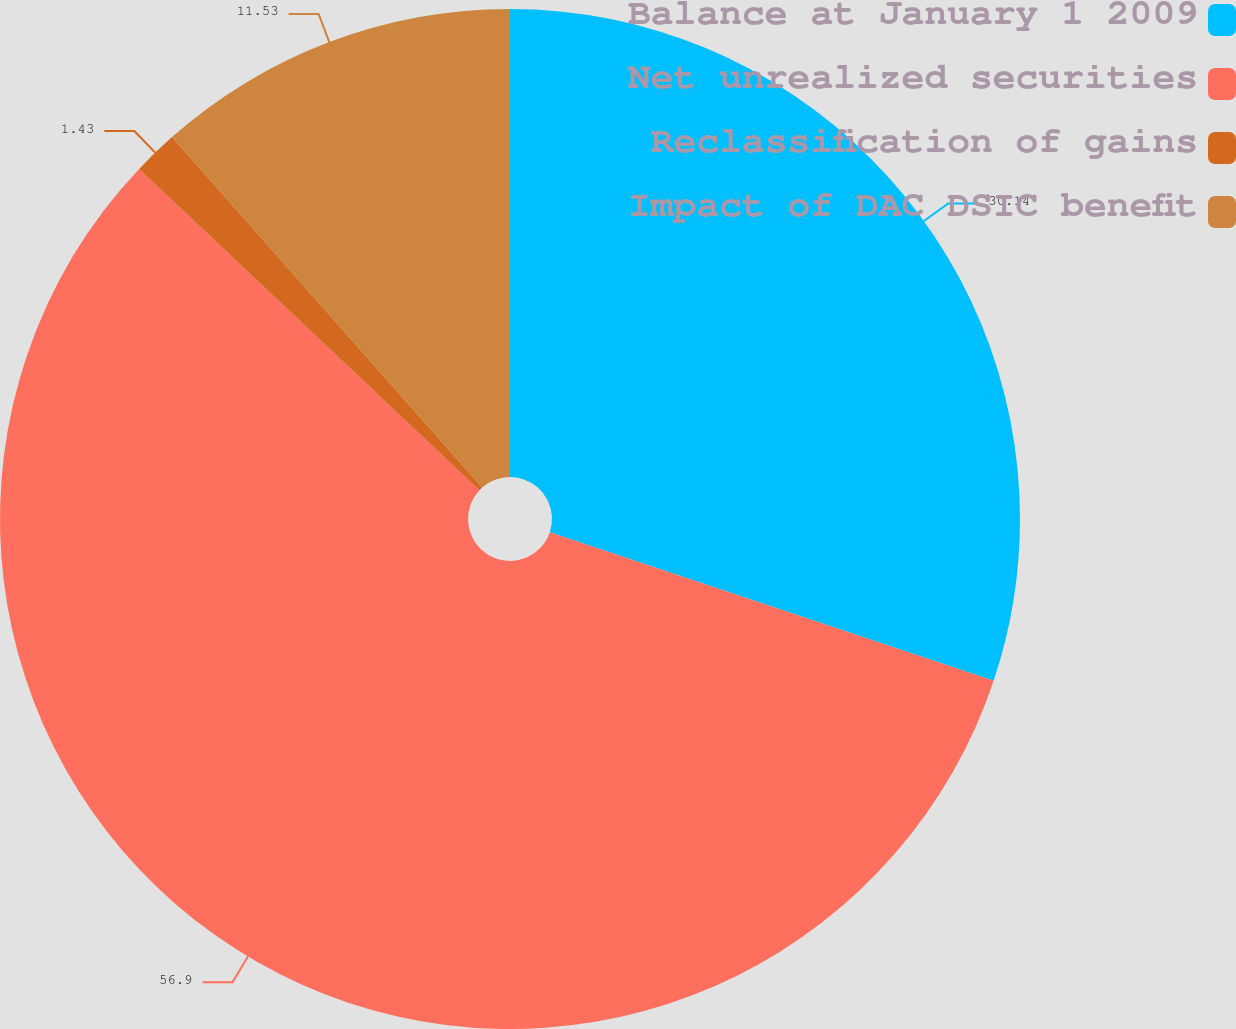<chart> <loc_0><loc_0><loc_500><loc_500><pie_chart><fcel>Balance at January 1 2009<fcel>Net unrealized securities<fcel>Reclassification of gains<fcel>Impact of DAC DSIC benefit<nl><fcel>30.14%<fcel>56.9%<fcel>1.43%<fcel>11.53%<nl></chart> 